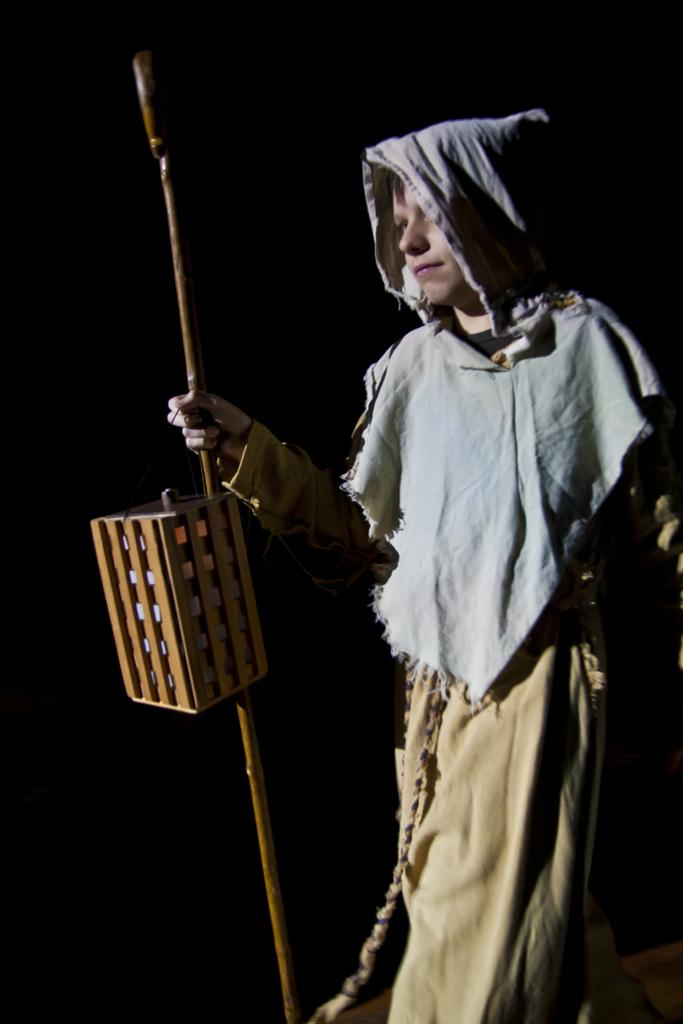What is the main subject of the image? There is a person in the image. What is the person holding in their hands? The person is holding a stick and a lantern. What type of surface is visible in the image? There is a floor visible in the image. What color is the person's toothbrush in the image? There is no toothbrush present in the image. Can you describe the veins on the person's lips in the image? There is no mention of the person's lips or veins in the provided facts, so we cannot answer this question. 